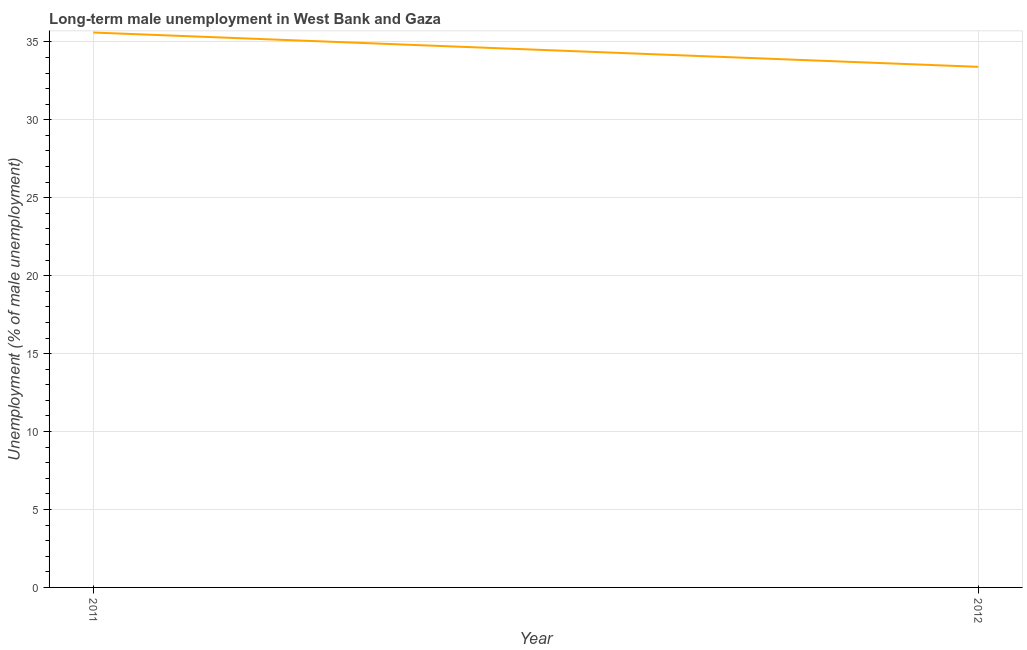What is the long-term male unemployment in 2012?
Give a very brief answer. 33.4. Across all years, what is the maximum long-term male unemployment?
Offer a very short reply. 35.6. Across all years, what is the minimum long-term male unemployment?
Offer a very short reply. 33.4. In which year was the long-term male unemployment minimum?
Ensure brevity in your answer.  2012. What is the difference between the long-term male unemployment in 2011 and 2012?
Offer a very short reply. 2.2. What is the average long-term male unemployment per year?
Offer a very short reply. 34.5. What is the median long-term male unemployment?
Your answer should be very brief. 34.5. What is the ratio of the long-term male unemployment in 2011 to that in 2012?
Offer a very short reply. 1.07. Is the long-term male unemployment in 2011 less than that in 2012?
Keep it short and to the point. No. In how many years, is the long-term male unemployment greater than the average long-term male unemployment taken over all years?
Offer a very short reply. 1. How many lines are there?
Your response must be concise. 1. How many years are there in the graph?
Your answer should be very brief. 2. Are the values on the major ticks of Y-axis written in scientific E-notation?
Keep it short and to the point. No. What is the title of the graph?
Offer a terse response. Long-term male unemployment in West Bank and Gaza. What is the label or title of the X-axis?
Your response must be concise. Year. What is the label or title of the Y-axis?
Provide a short and direct response. Unemployment (% of male unemployment). What is the Unemployment (% of male unemployment) in 2011?
Keep it short and to the point. 35.6. What is the Unemployment (% of male unemployment) in 2012?
Provide a succinct answer. 33.4. What is the difference between the Unemployment (% of male unemployment) in 2011 and 2012?
Your answer should be very brief. 2.2. What is the ratio of the Unemployment (% of male unemployment) in 2011 to that in 2012?
Give a very brief answer. 1.07. 